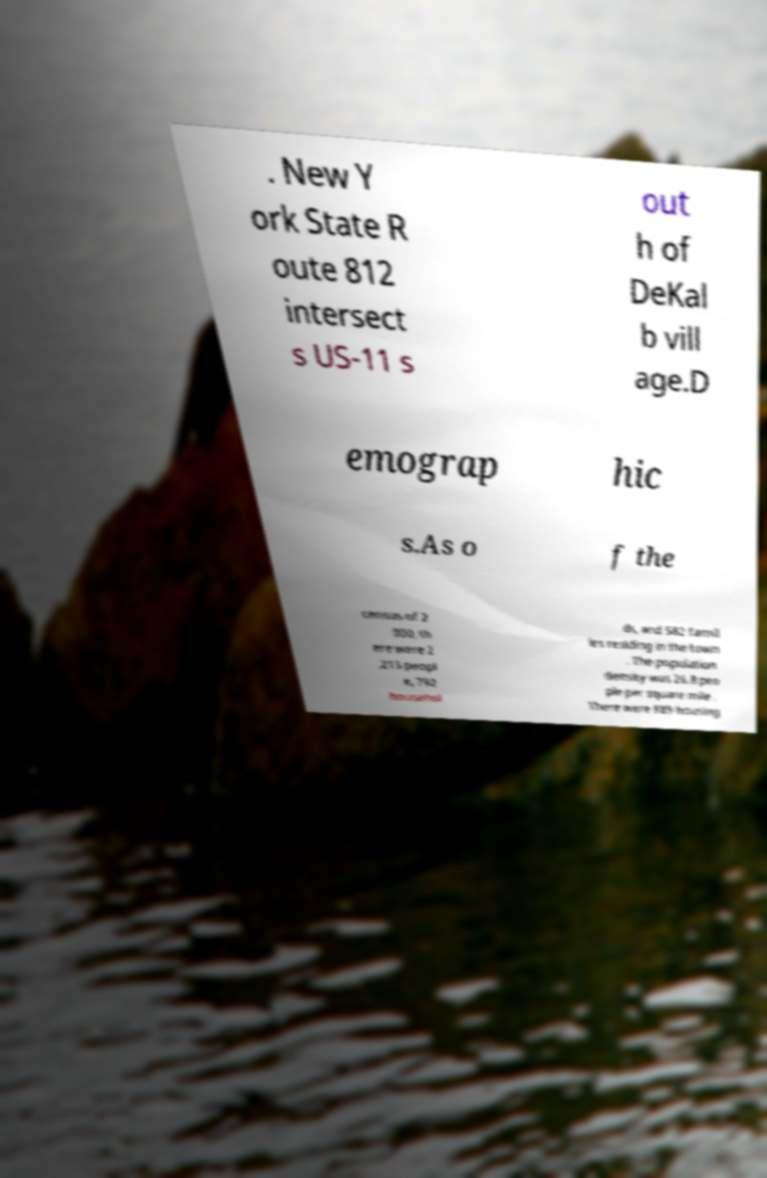Please read and relay the text visible in this image. What does it say? . New Y ork State R oute 812 intersect s US-11 s out h of DeKal b vill age.D emograp hic s.As o f the census of 2 000, th ere were 2 ,213 peopl e, 792 househol ds, and 582 famil ies residing in the town . The population density was 26.8 peo ple per square mile . There were 889 housing 